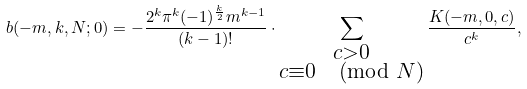<formula> <loc_0><loc_0><loc_500><loc_500>b ( - m , k , N ; 0 ) = - \frac { 2 ^ { k } \pi ^ { k } ( - 1 ) ^ { \frac { k } { 2 } } m ^ { k - 1 } } { ( k - 1 ) ! } \cdot \sum _ { \substack { c > 0 \\ c \equiv 0 \pmod { N } } } \frac { K ( - m , 0 , c ) } { c ^ { k } } ,</formula> 